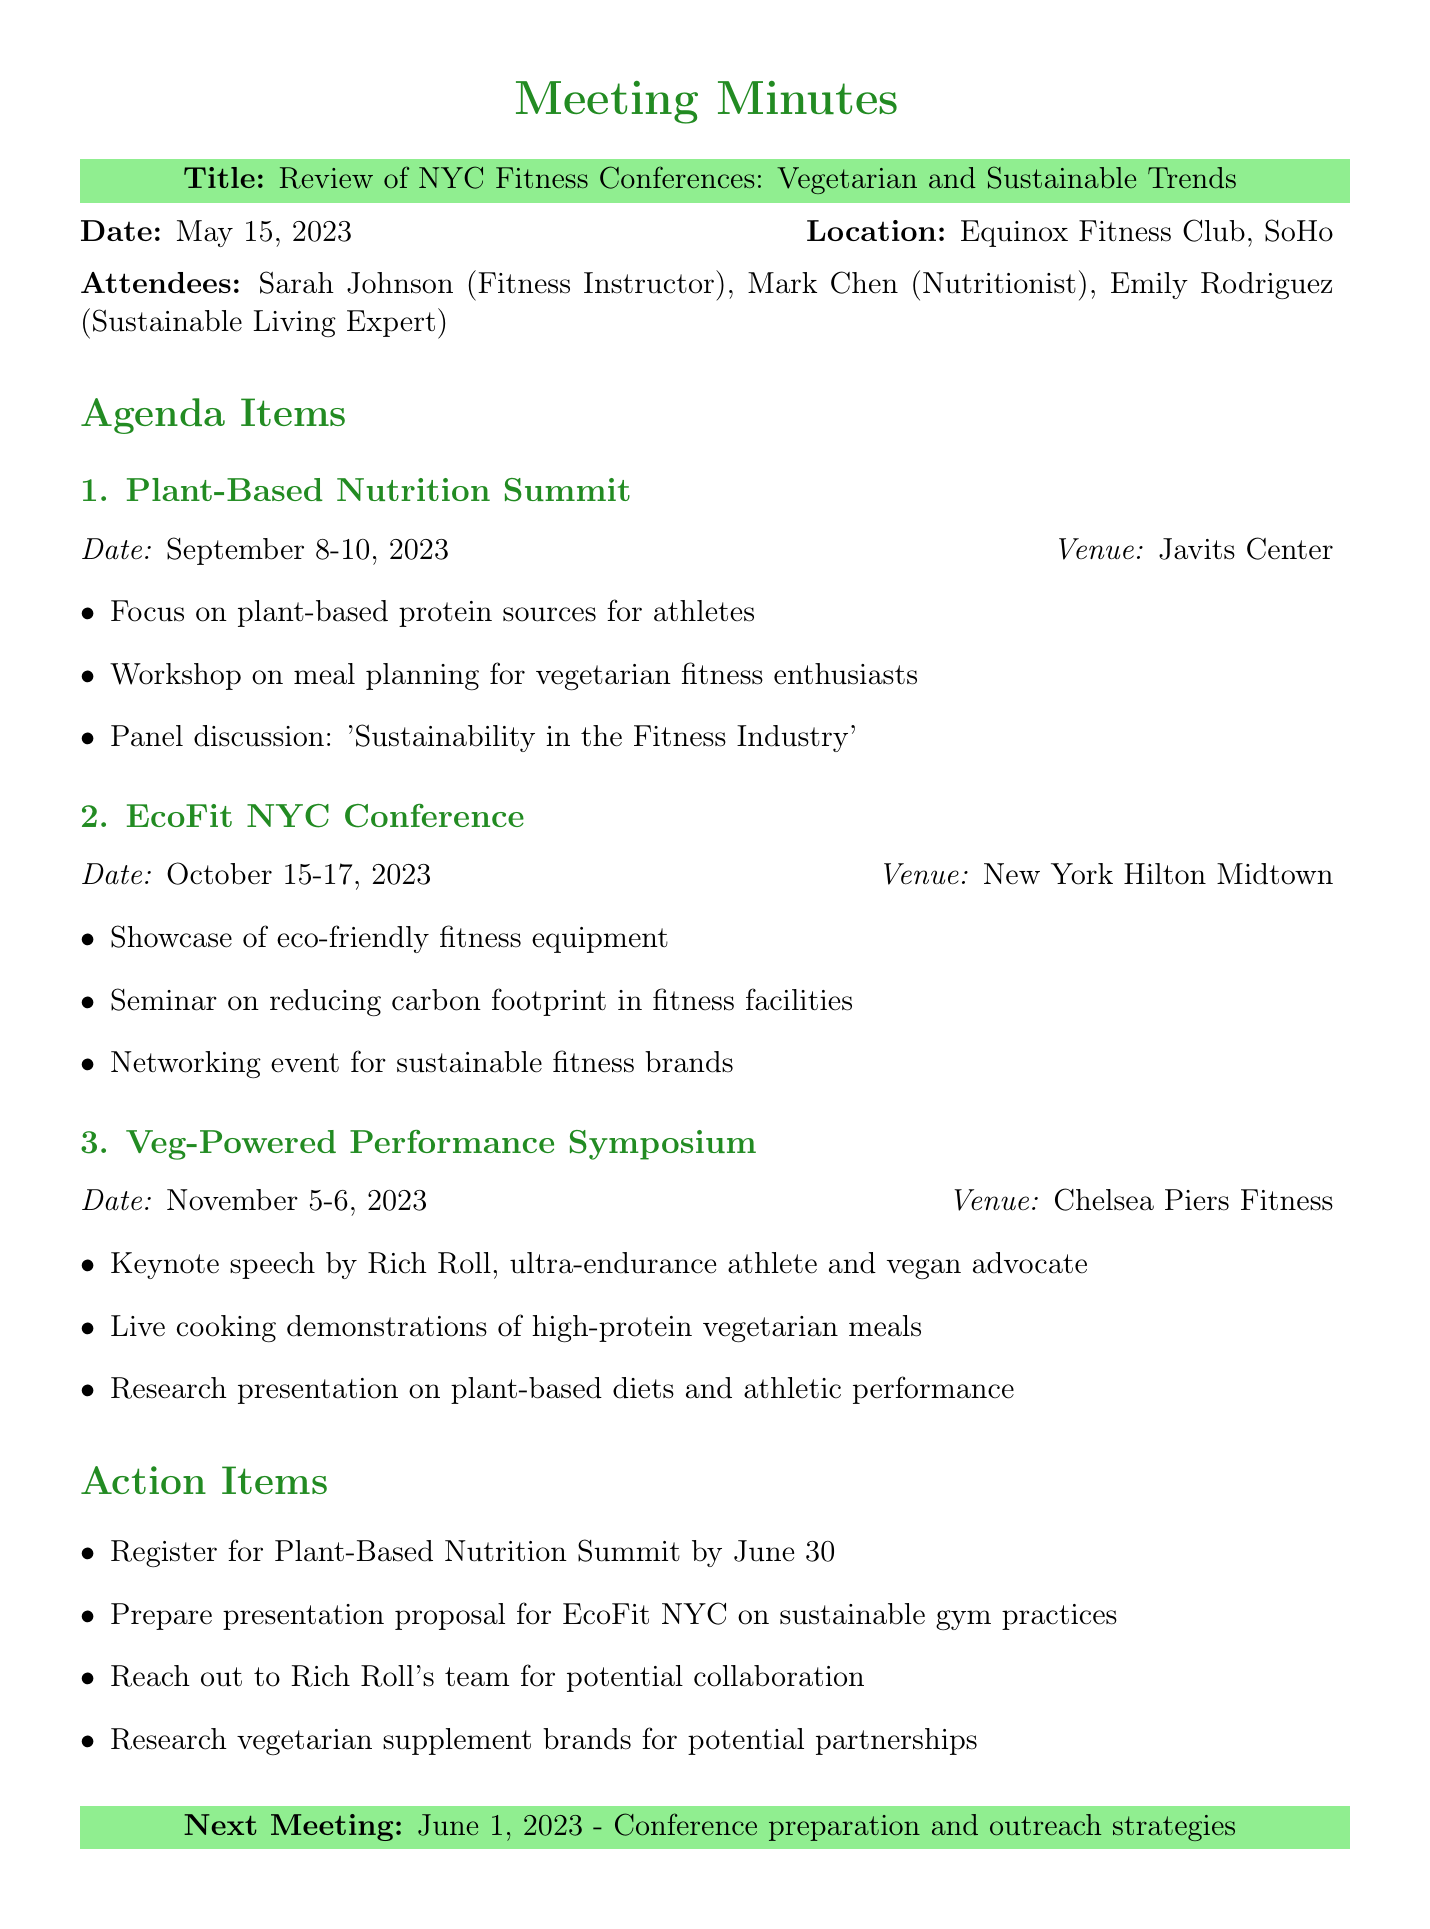What is the title of the meeting? The title of the meeting is found in the header section of the document.
Answer: Review of NYC Fitness Conferences: Vegetarian and Sustainable Trends Who is the keynote speaker at the Veg-Powered Performance Symposium? The keynote speaker is mentioned under the agenda item for the Veg-Powered Performance Symposium.
Answer: Rich Roll What are the dates for the EcoFit NYC Conference? The dates for the EcoFit NYC Conference are stated under its respective agenda section.
Answer: October 15-17, 2023 What is one of the action items listed in the document? Action items are listed in a section towards the end of the document.
Answer: Register for Plant-Based Nutrition Summit by June 30 Which venue will host the Plant-Based Nutrition Summit? The venue for the Plant-Based Nutrition Summit is specified in the agenda item for that event.
Answer: Javits Center What is the primary focus of the Plant-Based Nutrition Summit? This information can be found in the key points for that conference in the agenda section.
Answer: Plant-based protein sources for athletes What is the next meeting date? The next meeting date is listed at the bottom of the document.
Answer: June 1, 2023 Which brand is suggested for potential collaboration outreach? The specific brand mentioned for outreach is included in the action items section.
Answer: Rich Roll's team 